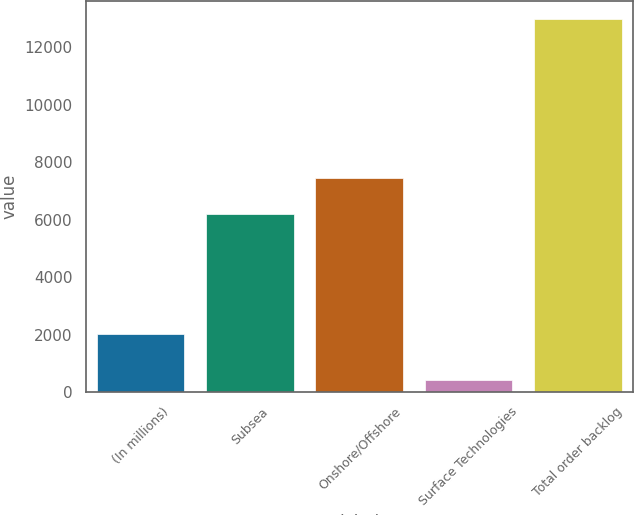Convert chart to OTSL. <chart><loc_0><loc_0><loc_500><loc_500><bar_chart><fcel>(In millions)<fcel>Subsea<fcel>Onshore/Offshore<fcel>Surface Technologies<fcel>Total order backlog<nl><fcel>2017<fcel>6203.9<fcel>7461.2<fcel>409.8<fcel>12982.8<nl></chart> 